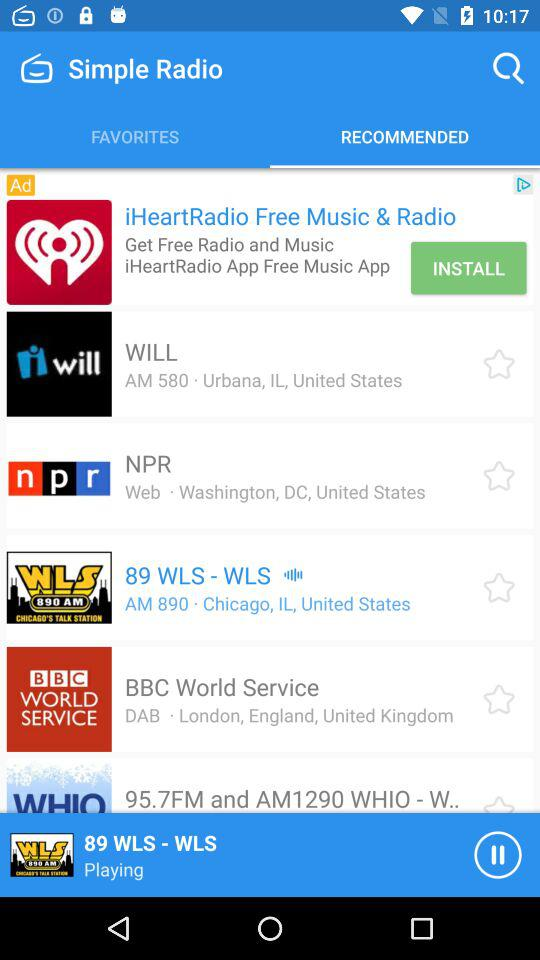Which channel is playing? The playing channel is "89 WLS - WLS". 